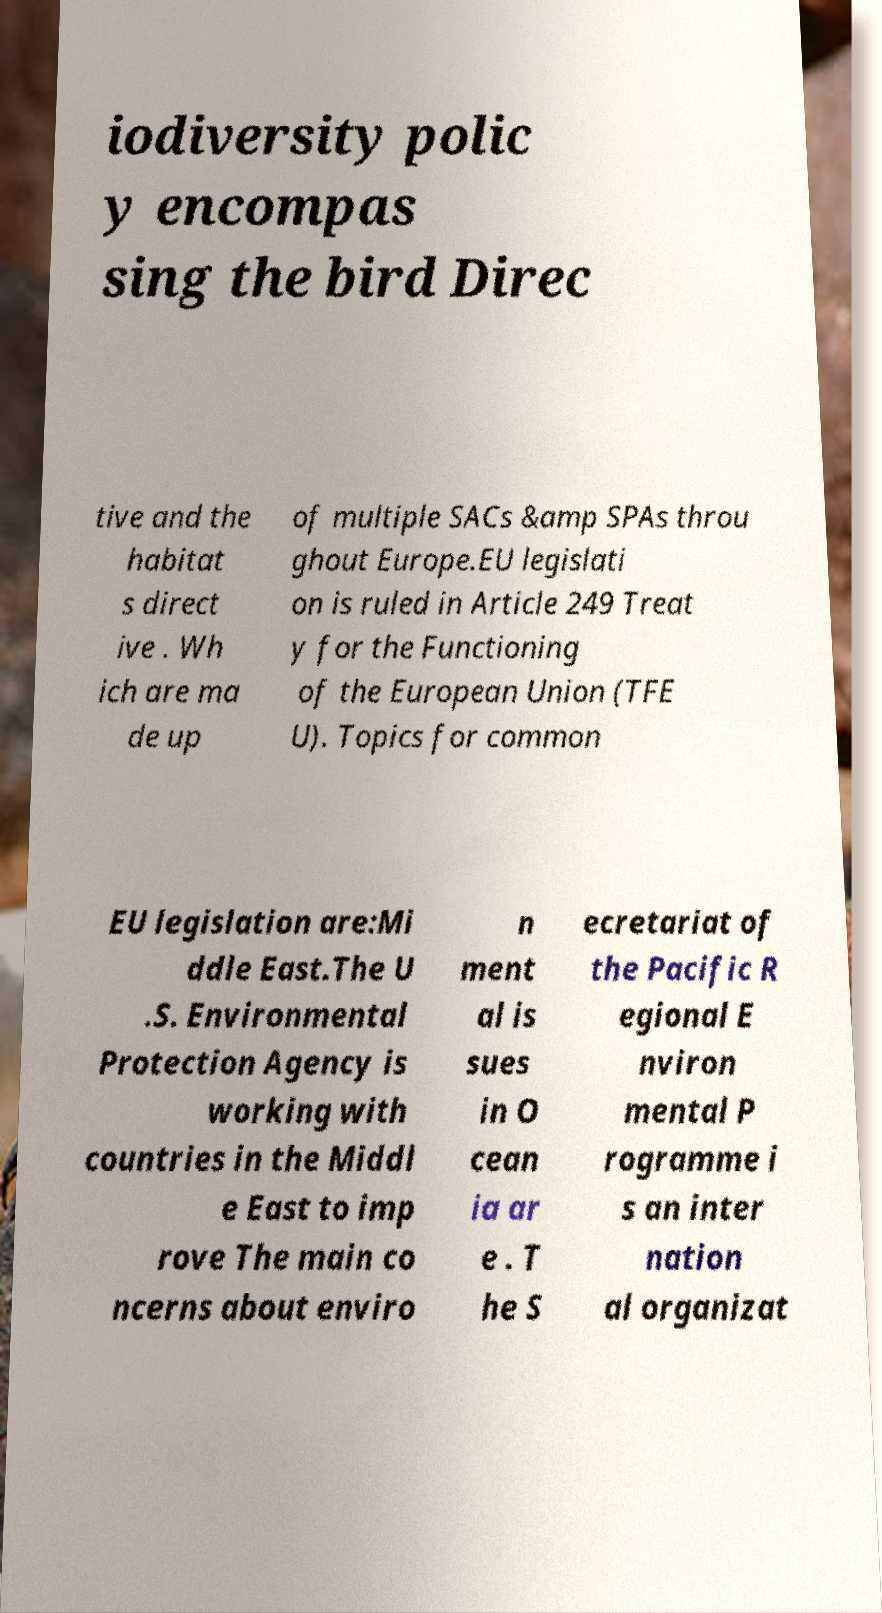Could you extract and type out the text from this image? iodiversity polic y encompas sing the bird Direc tive and the habitat s direct ive . Wh ich are ma de up of multiple SACs &amp SPAs throu ghout Europe.EU legislati on is ruled in Article 249 Treat y for the Functioning of the European Union (TFE U). Topics for common EU legislation are:Mi ddle East.The U .S. Environmental Protection Agency is working with countries in the Middl e East to imp rove The main co ncerns about enviro n ment al is sues in O cean ia ar e . T he S ecretariat of the Pacific R egional E nviron mental P rogramme i s an inter nation al organizat 